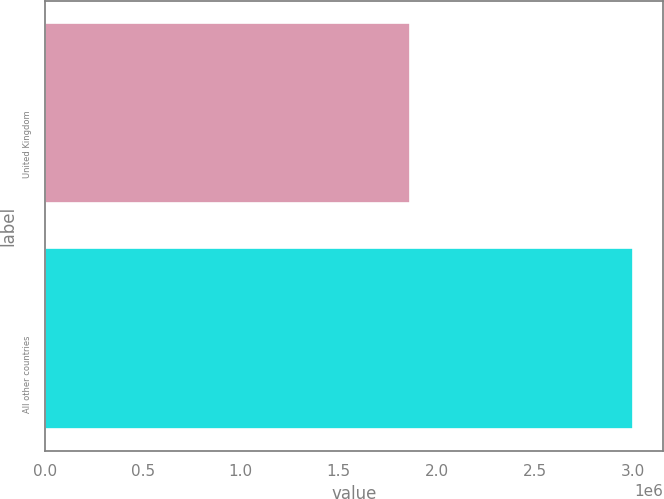Convert chart. <chart><loc_0><loc_0><loc_500><loc_500><bar_chart><fcel>United Kingdom<fcel>All other countries<nl><fcel>1.8612e+06<fcel>3.00278e+06<nl></chart> 